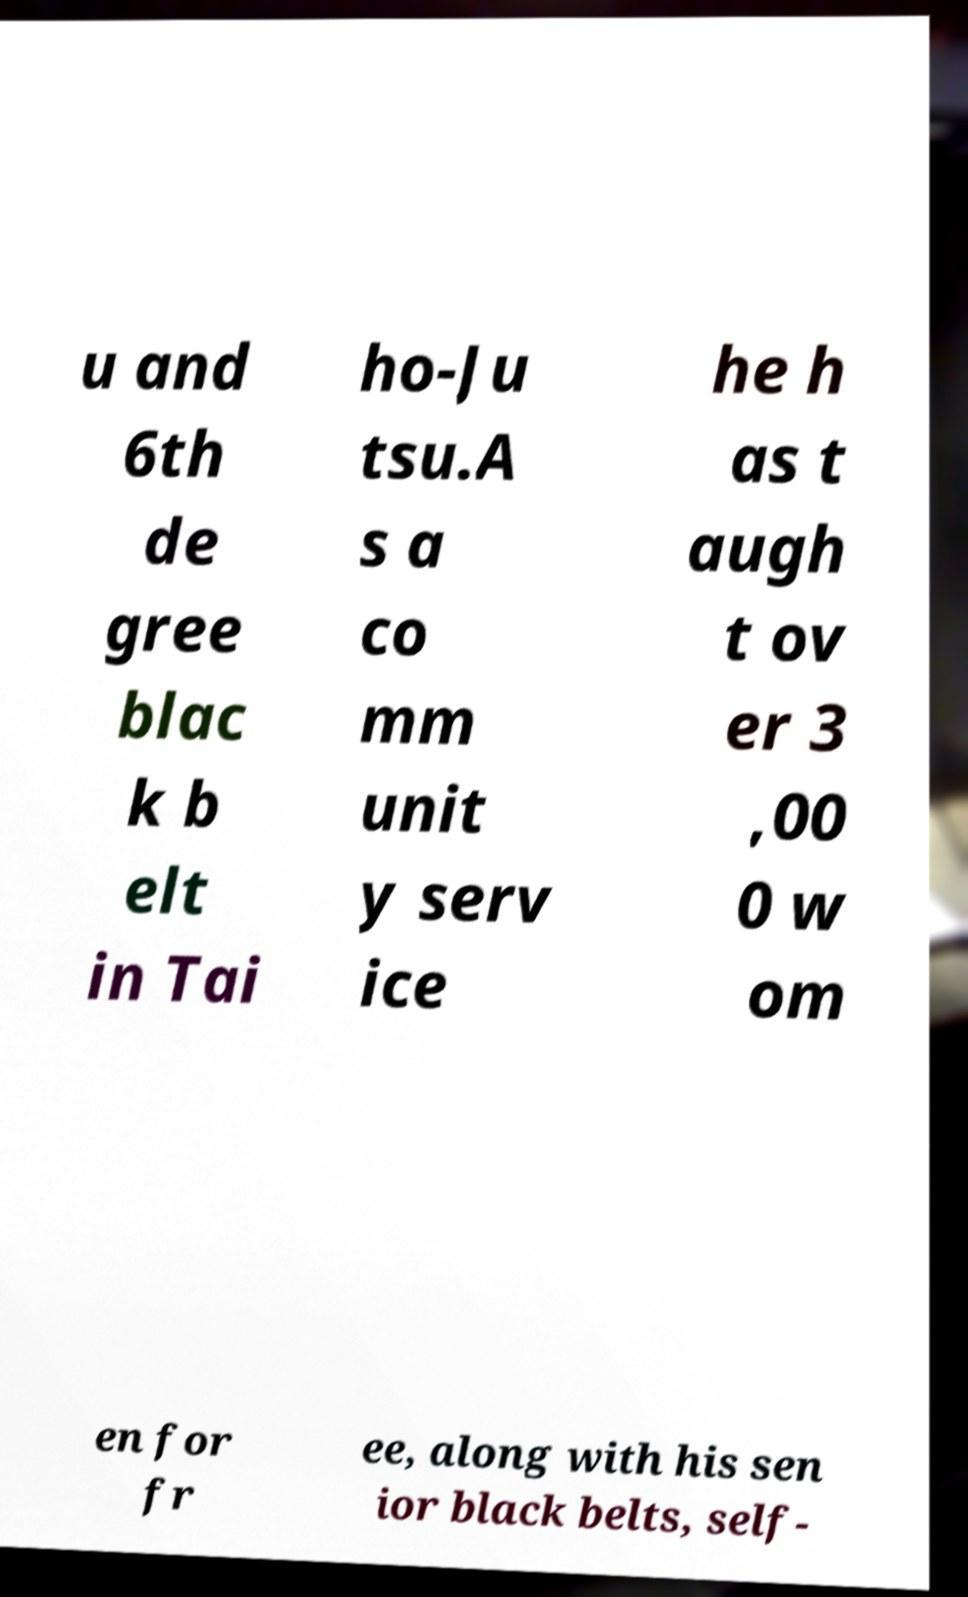I need the written content from this picture converted into text. Can you do that? u and 6th de gree blac k b elt in Tai ho-Ju tsu.A s a co mm unit y serv ice he h as t augh t ov er 3 ,00 0 w om en for fr ee, along with his sen ior black belts, self- 